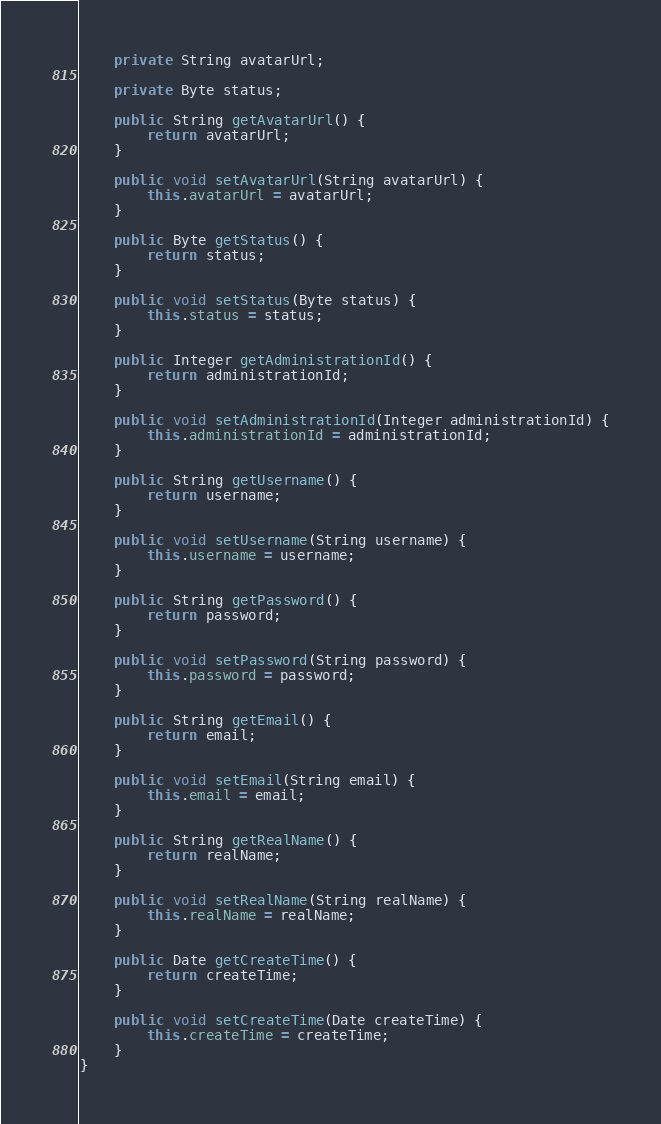Convert code to text. <code><loc_0><loc_0><loc_500><loc_500><_Java_>
    private String avatarUrl;

    private Byte status;

    public String getAvatarUrl() {
        return avatarUrl;
    }

    public void setAvatarUrl(String avatarUrl) {
        this.avatarUrl = avatarUrl;
    }

    public Byte getStatus() {
        return status;
    }

    public void setStatus(Byte status) {
        this.status = status;
    }

    public Integer getAdministrationId() {
        return administrationId;
    }

    public void setAdministrationId(Integer administrationId) {
        this.administrationId = administrationId;
    }

    public String getUsername() {
        return username;
    }

    public void setUsername(String username) {
        this.username = username;
    }

    public String getPassword() {
        return password;
    }

    public void setPassword(String password) {
        this.password = password;
    }

    public String getEmail() {
        return email;
    }

    public void setEmail(String email) {
        this.email = email;
    }

    public String getRealName() {
        return realName;
    }

    public void setRealName(String realName) {
        this.realName = realName;
    }

    public Date getCreateTime() {
        return createTime;
    }

    public void setCreateTime(Date createTime) {
        this.createTime = createTime;
    }
}
</code> 